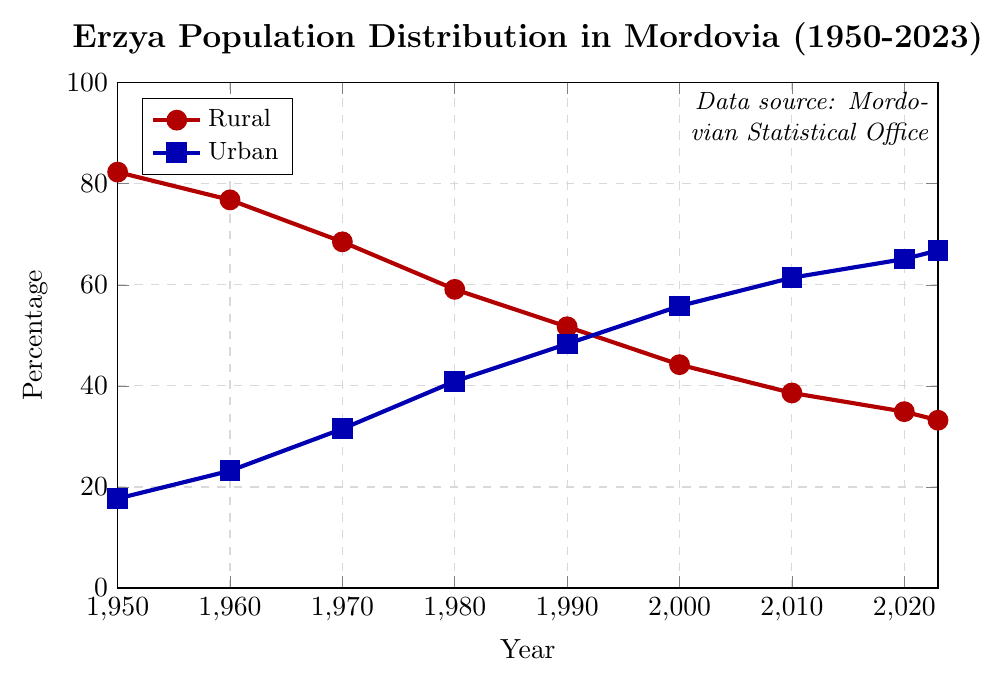What is the percentage of Erzya people living in rural areas in 1950? According to the figure, the percentage of Erzya people living in rural areas in 1950 is represented by the red line at the value of 82.3%.
Answer: 82.3% What can you say about the trend in the percentage of Erzya people living in urban areas from 1950 to 2023? The blue line in the figure shows a continuous increase in the percentage of Erzya people living in urban areas, starting at 17.7% in 1950 and reaching 66.8% in 2023.
Answer: Continuous increase How did the distribution of Erzya people in rural areas change between 1950 and 2000? In 1950, the rural percentage was 82.3%, and it dropped to 44.2% by 2000. This shows a substantial decrease.
Answer: Substantial decrease What trend can be observed in the Erzya population's move from rural to urban areas over the 70-year span? The figure shows a clear trend of urbanization, with the percentage of Erzya people in rural areas decreasing from 82.3% in 1950 to 33.2% in 2023, and the percentage in urban areas increasing from 17.7% to 66.8%.
Answer: Trend of urbanization In which decade did the Erzya population see the largest decrease in the rural percentage? The largest decrease in the rural percentage occurred between 1970 (68.5%) and 1980 (59.1%), dropping by 9.4%.
Answer: 1970-1980 Compare the percentage change of the rural Erzya population between the decades 1950-1960 and 1960-1970. Which decade saw a larger change? From 1950 to 1960, the rural percentage changed from 82.3% to 76.8%, a decrease of 5.5%. From 1960 to 1970, it changed from 76.8% to 68.5%, a decrease of 8.3%. The second decade saw a larger change.
Answer: 1960-1970 